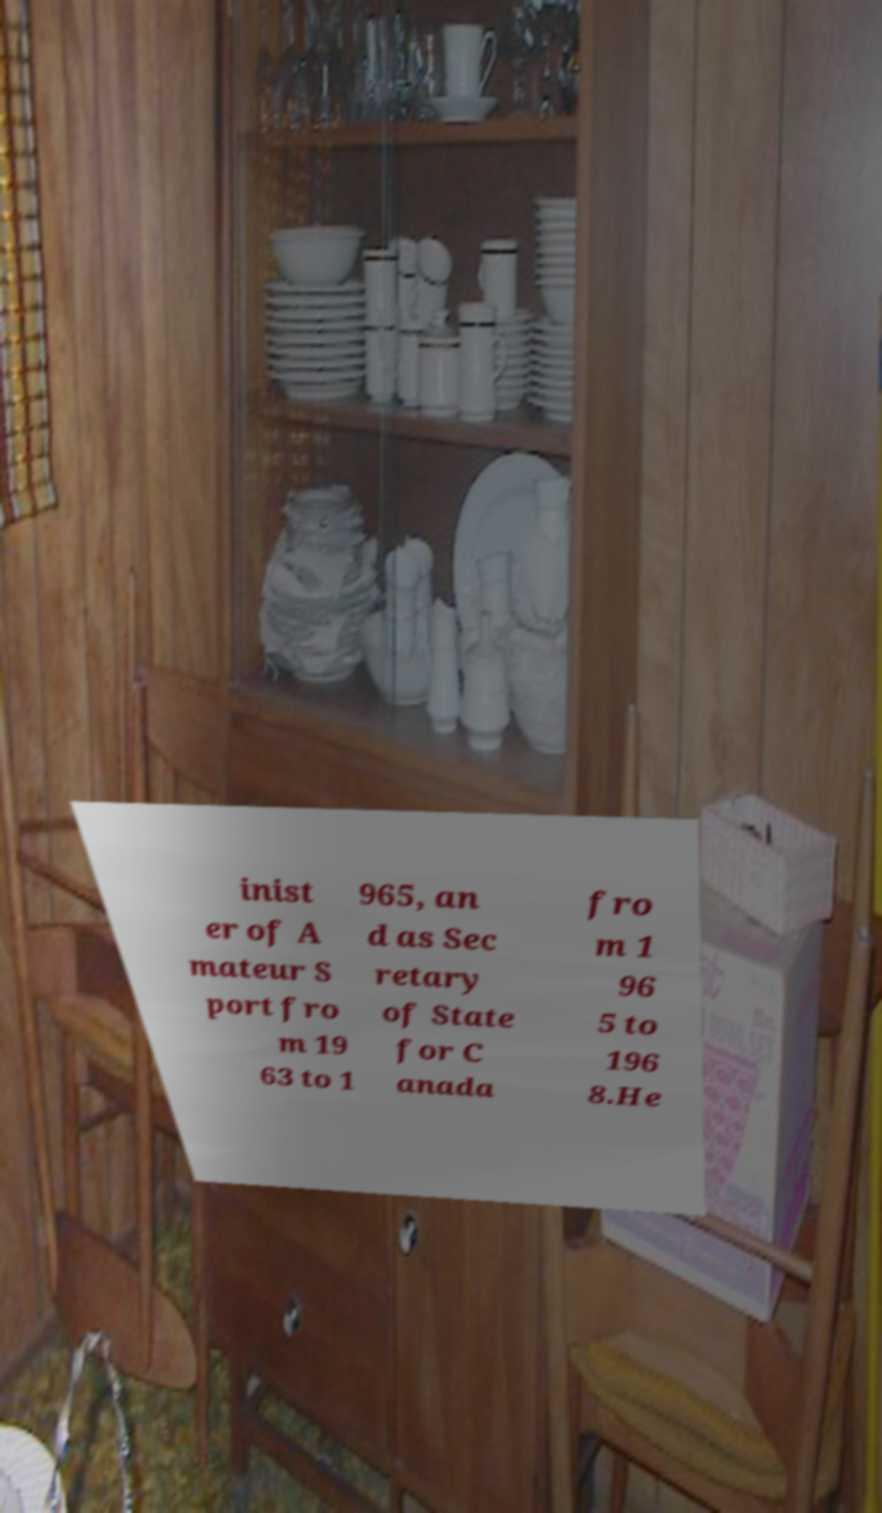What messages or text are displayed in this image? I need them in a readable, typed format. inist er of A mateur S port fro m 19 63 to 1 965, an d as Sec retary of State for C anada fro m 1 96 5 to 196 8.He 